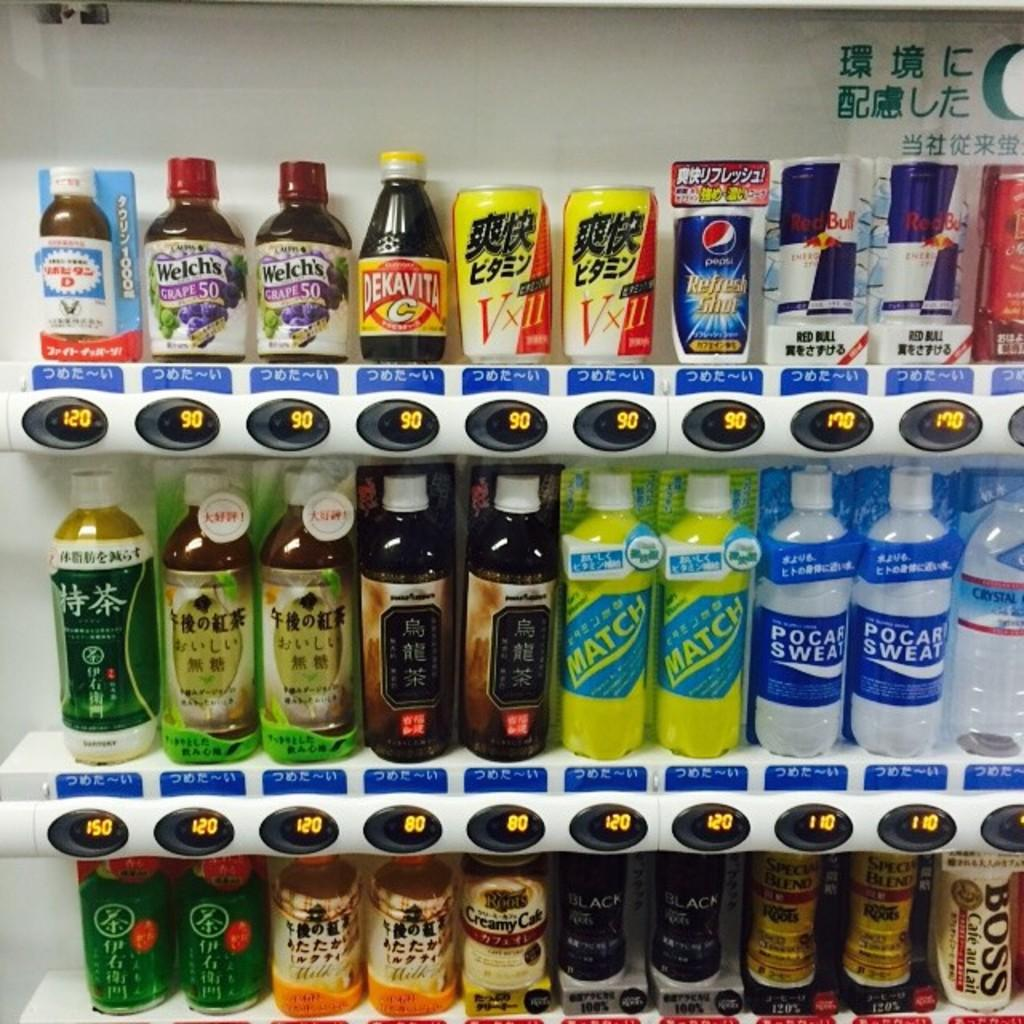What is the main object in the image? There is a vending machine in the image. How many shelves does the vending machine have? The vending machine has three shelves. What types of beverages are displayed on the shelves? The shelves showcase different types of energy drinks, cool drinks, and water bottles. Are the prices of the items visible in the image? Yes, prices are displayed below the items on the shelves. What type of crack can be seen on the chin of the person in the image? There is: There is no person present in the image, and therefore no crack or chin can be observed. 